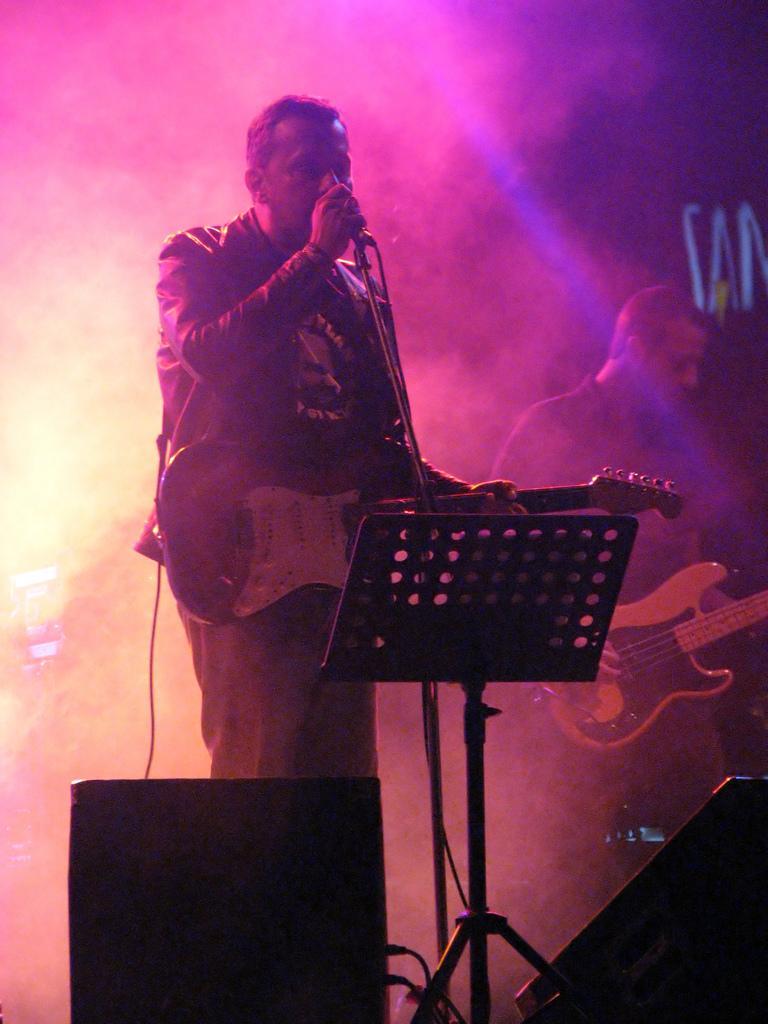Can you describe this image briefly? As we can see in the image there is a man holding mic and on the right side there is another man holding a guitar. In the front there is sound box and there is smoke. 